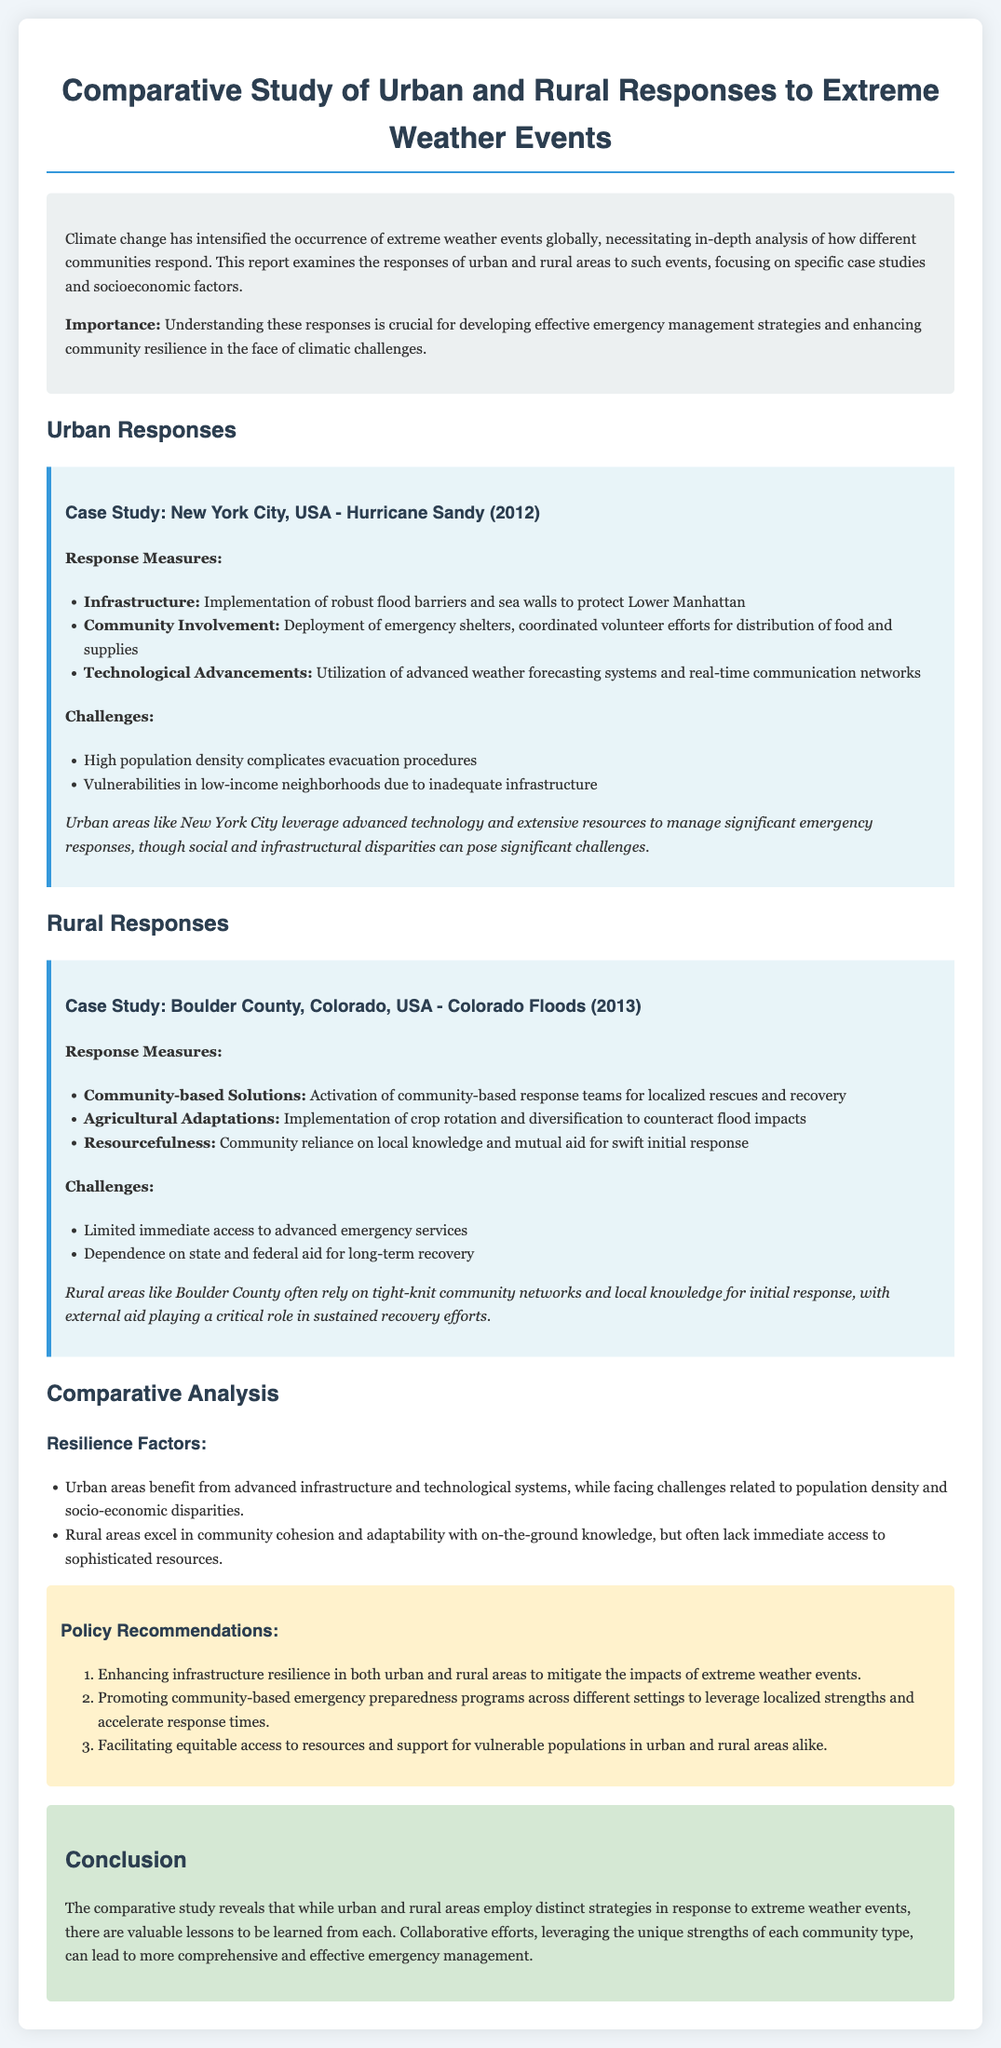What was the case study for urban response? The report provides a specific case study of urban response focusing on Hurricane Sandy in New York City, highlighting its unique challenges and measures.
Answer: Hurricane Sandy (2012) What community involvement measures were taken in New York City? The document lists emergency shelters and coordinated volunteer efforts for food and supplies as key community involvement measures during Hurricane Sandy.
Answer: Emergency shelters What was a significant challenge faced by urban areas like New York City? The report mentions that high population density complicates evacuation procedures as a significant challenge in urban areas during extreme weather events.
Answer: High population density What type of solutions were implemented in Boulder County? The report highlights that community-based solutions were key measures taken in Boulder County during the Colorado floods, focusing on local response teams.
Answer: Community-based solutions What resource did Boulder County rely on for initial response? The document indicates that Boulder County relied on local knowledge and mutual aid for a swift initial response during extreme weather events.
Answer: Local knowledge How many policy recommendations are provided in the report? The report lists three distinct policy recommendations aimed at improving emergency management and resilience against extreme weather events.
Answer: Three What year did the Colorado floods occur? The document specifies the year of the Colorado floods case study in Boulder County as 2013.
Answer: 2013 What is noted as a challenge for rural areas in their response? The report outlines that rural areas face the challenge of limited immediate access to advanced emergency services during extreme weather events.
Answer: Limited access What is emphasized as a conclusion regarding the responses of urban and rural areas? The report concludes that while urban and rural responses are distinct, there are valuable lessons to be learned from each community type's emergency management strategies.
Answer: Valuable lessons 